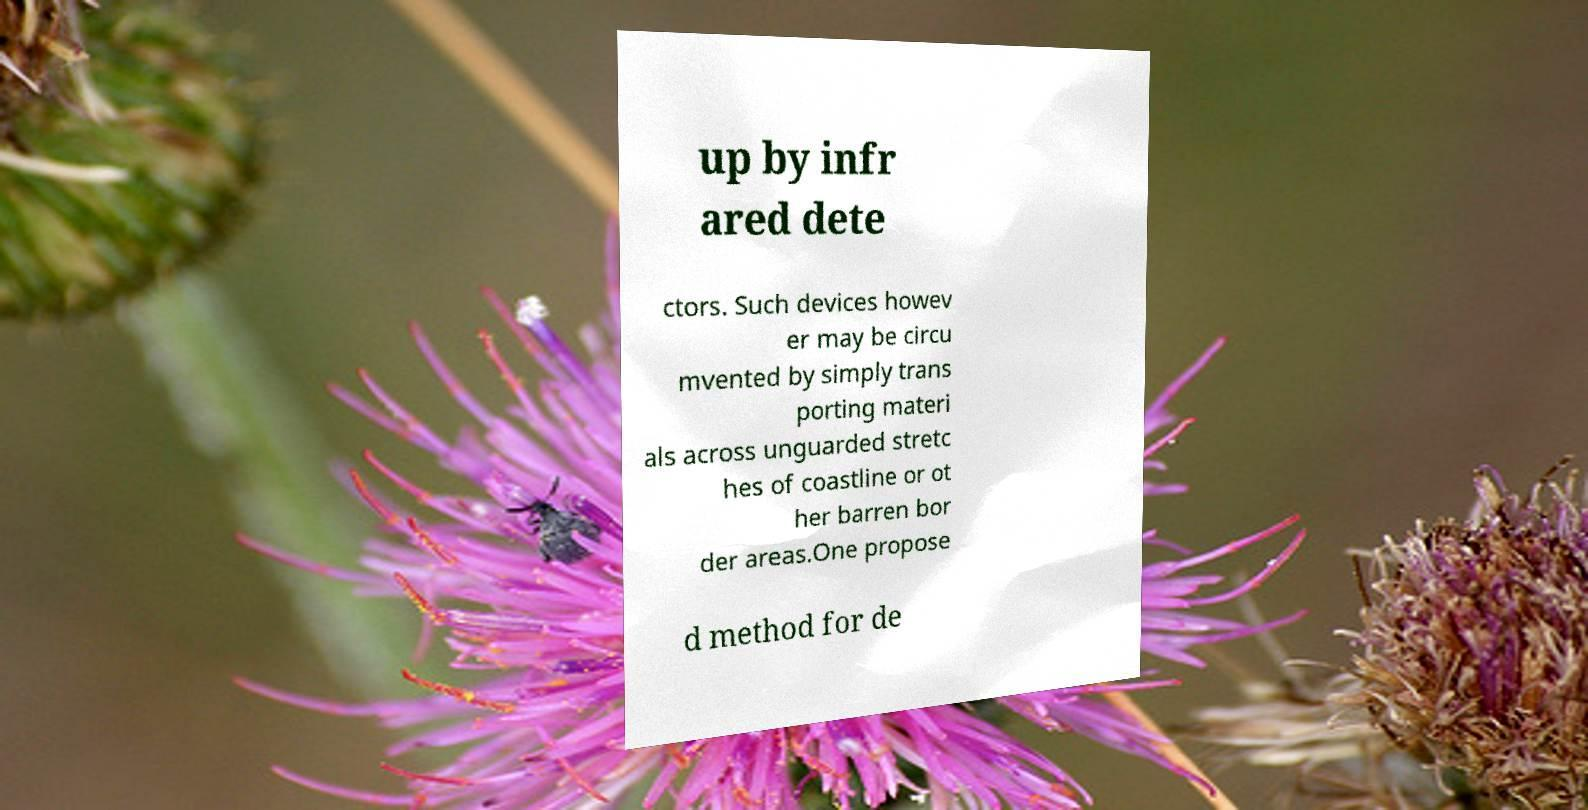Could you extract and type out the text from this image? up by infr ared dete ctors. Such devices howev er may be circu mvented by simply trans porting materi als across unguarded stretc hes of coastline or ot her barren bor der areas.One propose d method for de 